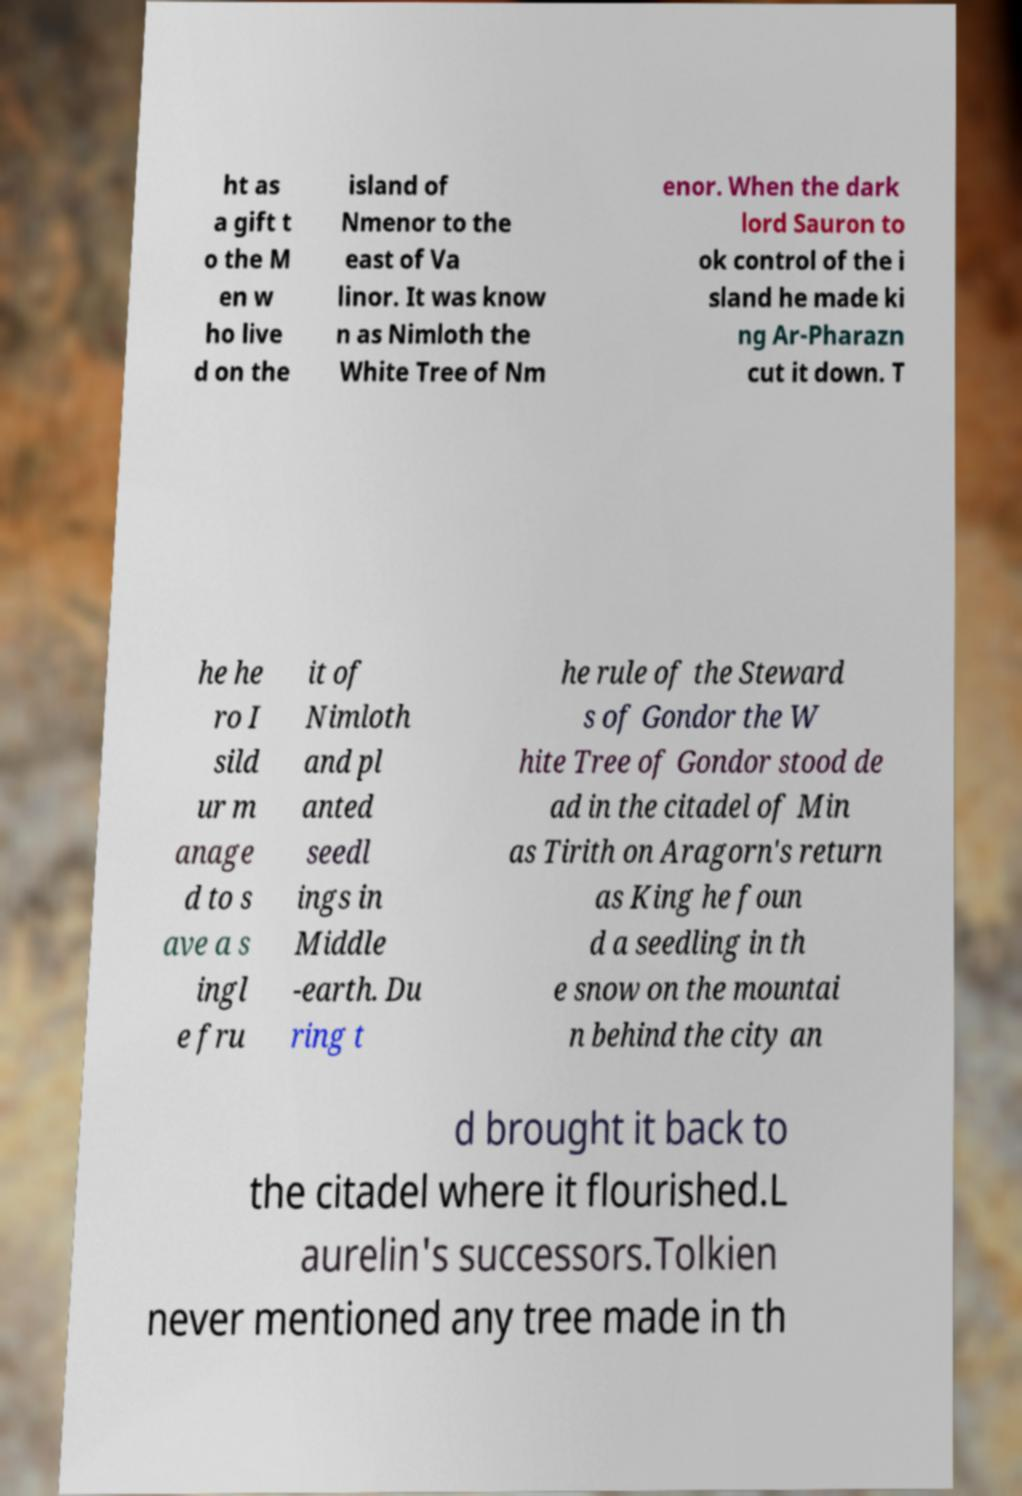What messages or text are displayed in this image? I need them in a readable, typed format. ht as a gift t o the M en w ho live d on the island of Nmenor to the east of Va linor. It was know n as Nimloth the White Tree of Nm enor. When the dark lord Sauron to ok control of the i sland he made ki ng Ar-Pharazn cut it down. T he he ro I sild ur m anage d to s ave a s ingl e fru it of Nimloth and pl anted seedl ings in Middle -earth. Du ring t he rule of the Steward s of Gondor the W hite Tree of Gondor stood de ad in the citadel of Min as Tirith on Aragorn's return as King he foun d a seedling in th e snow on the mountai n behind the city an d brought it back to the citadel where it flourished.L aurelin's successors.Tolkien never mentioned any tree made in th 